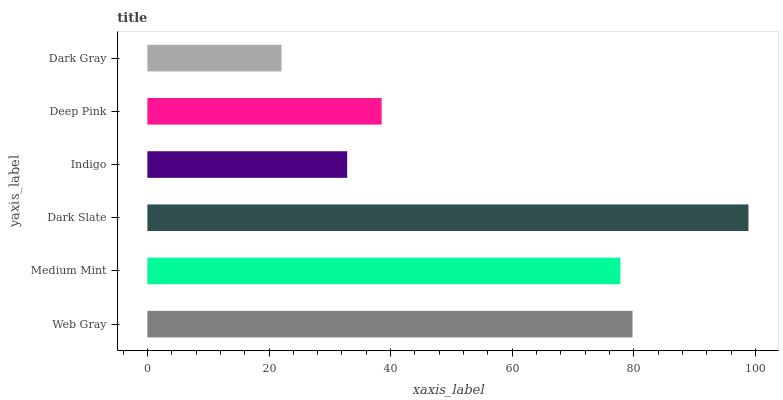Is Dark Gray the minimum?
Answer yes or no. Yes. Is Dark Slate the maximum?
Answer yes or no. Yes. Is Medium Mint the minimum?
Answer yes or no. No. Is Medium Mint the maximum?
Answer yes or no. No. Is Web Gray greater than Medium Mint?
Answer yes or no. Yes. Is Medium Mint less than Web Gray?
Answer yes or no. Yes. Is Medium Mint greater than Web Gray?
Answer yes or no. No. Is Web Gray less than Medium Mint?
Answer yes or no. No. Is Medium Mint the high median?
Answer yes or no. Yes. Is Deep Pink the low median?
Answer yes or no. Yes. Is Web Gray the high median?
Answer yes or no. No. Is Indigo the low median?
Answer yes or no. No. 